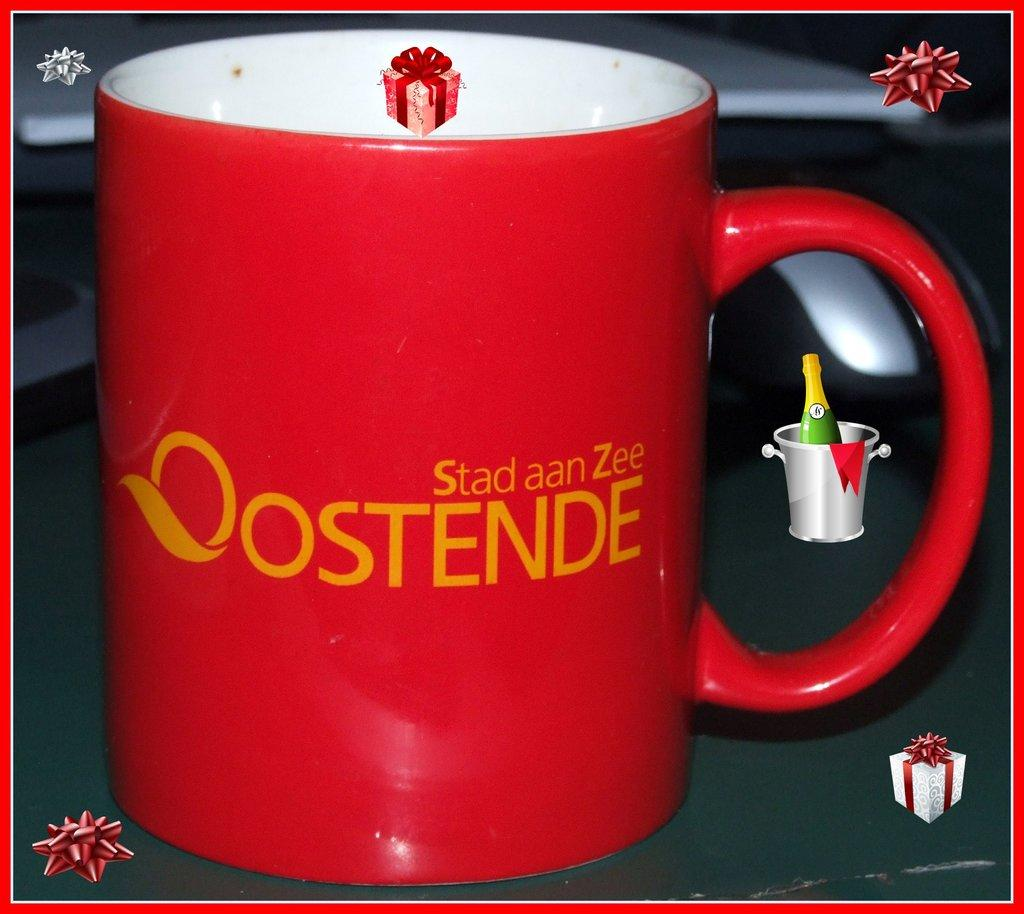<image>
Provide a brief description of the given image. A cup with the words Stad aan Zee oostende on it. 